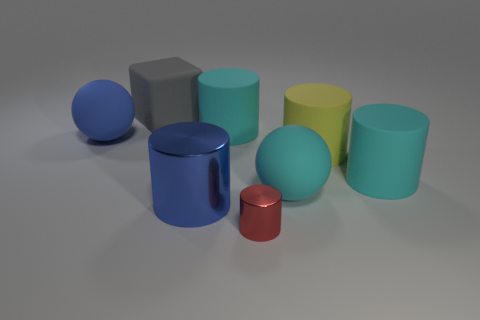Subtract all gray balls. How many cyan cylinders are left? 2 Subtract all red cylinders. How many cylinders are left? 4 Subtract all large cylinders. How many cylinders are left? 1 Add 1 metallic cylinders. How many objects exist? 9 Subtract all spheres. How many objects are left? 6 Subtract all blue cylinders. Subtract all red blocks. How many cylinders are left? 4 Add 4 large blue cylinders. How many large blue cylinders are left? 5 Add 8 red objects. How many red objects exist? 9 Subtract 0 brown cylinders. How many objects are left? 8 Subtract all big shiny things. Subtract all tiny gray cylinders. How many objects are left? 7 